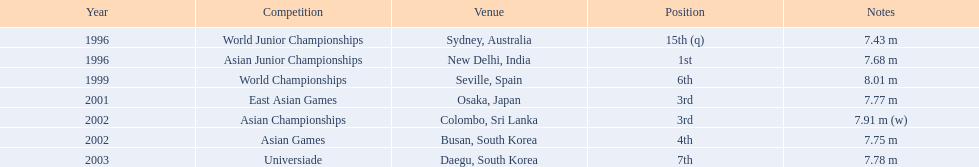I'm looking to parse the entire table for insights. Could you assist me with that? {'header': ['Year', 'Competition', 'Venue', 'Position', 'Notes'], 'rows': [['1996', 'World Junior Championships', 'Sydney, Australia', '15th (q)', '7.43 m'], ['1996', 'Asian Junior Championships', 'New Delhi, India', '1st', '7.68 m'], ['1999', 'World Championships', 'Seville, Spain', '6th', '8.01 m'], ['2001', 'East Asian Games', 'Osaka, Japan', '3rd', '7.77 m'], ['2002', 'Asian Championships', 'Colombo, Sri Lanka', '3rd', '7.91 m (w)'], ['2002', 'Asian Games', 'Busan, South Korea', '4th', '7.75 m'], ['2003', 'Universiade', 'Daegu, South Korea', '7th', '7.78 m']]} What is the variation between the count of third-place achievements and the count of first-place achievements? 1. 